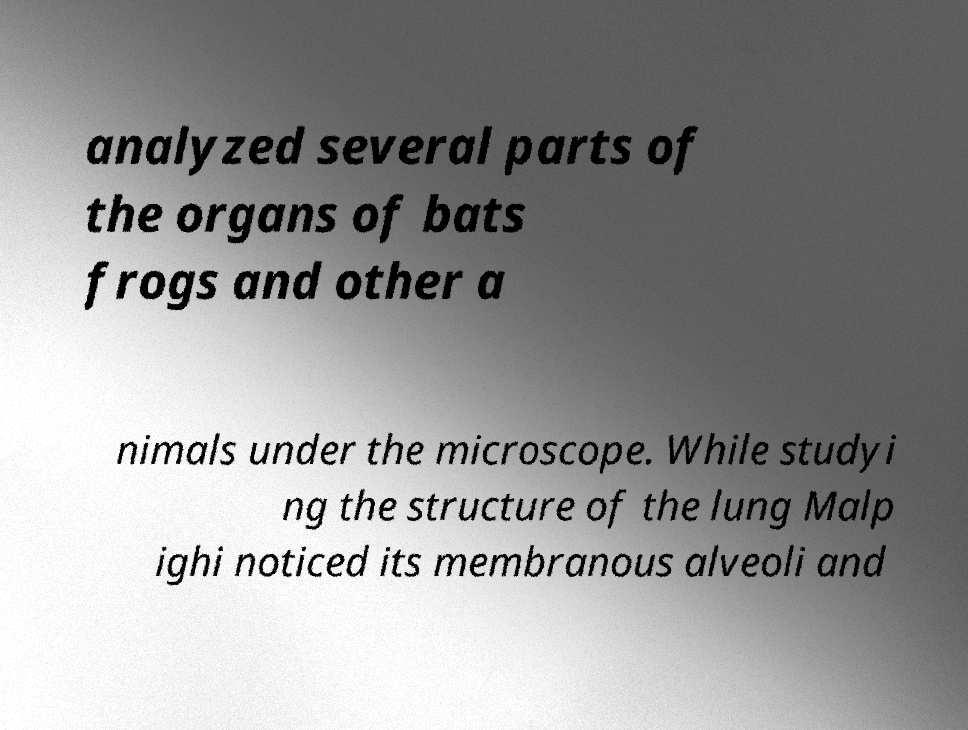Could you assist in decoding the text presented in this image and type it out clearly? analyzed several parts of the organs of bats frogs and other a nimals under the microscope. While studyi ng the structure of the lung Malp ighi noticed its membranous alveoli and 